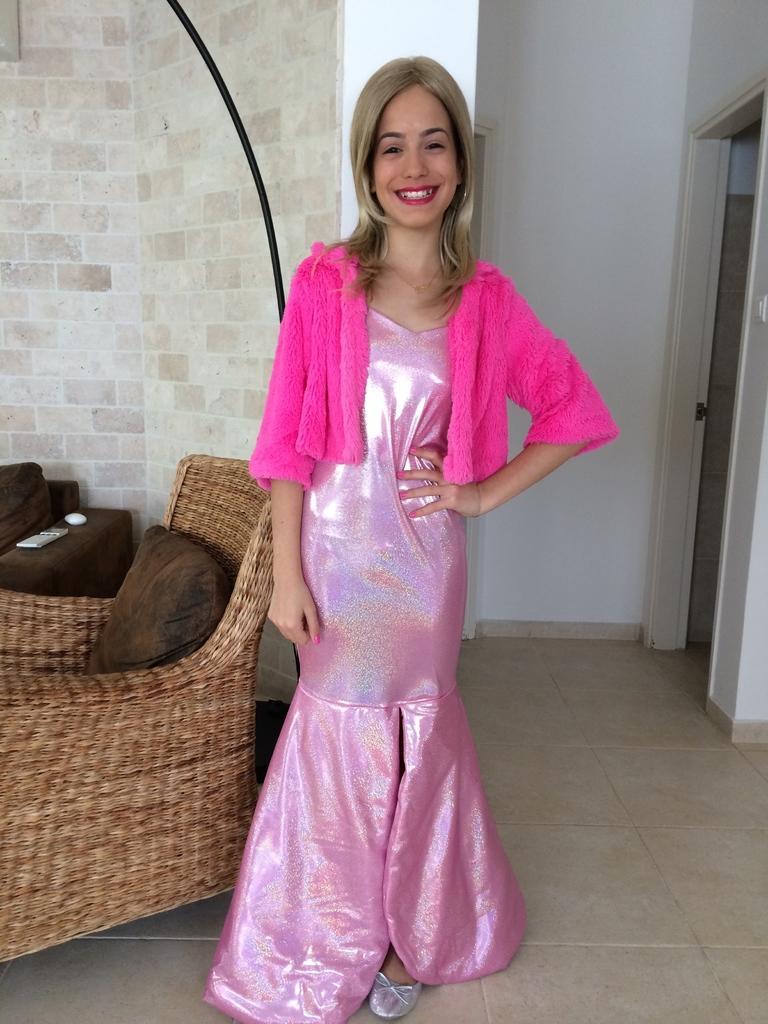Please provide a concise description of this image. In this image I can see the person with pink color dress. To the left I can see the couches and pillows. In the background I can see the wall. 